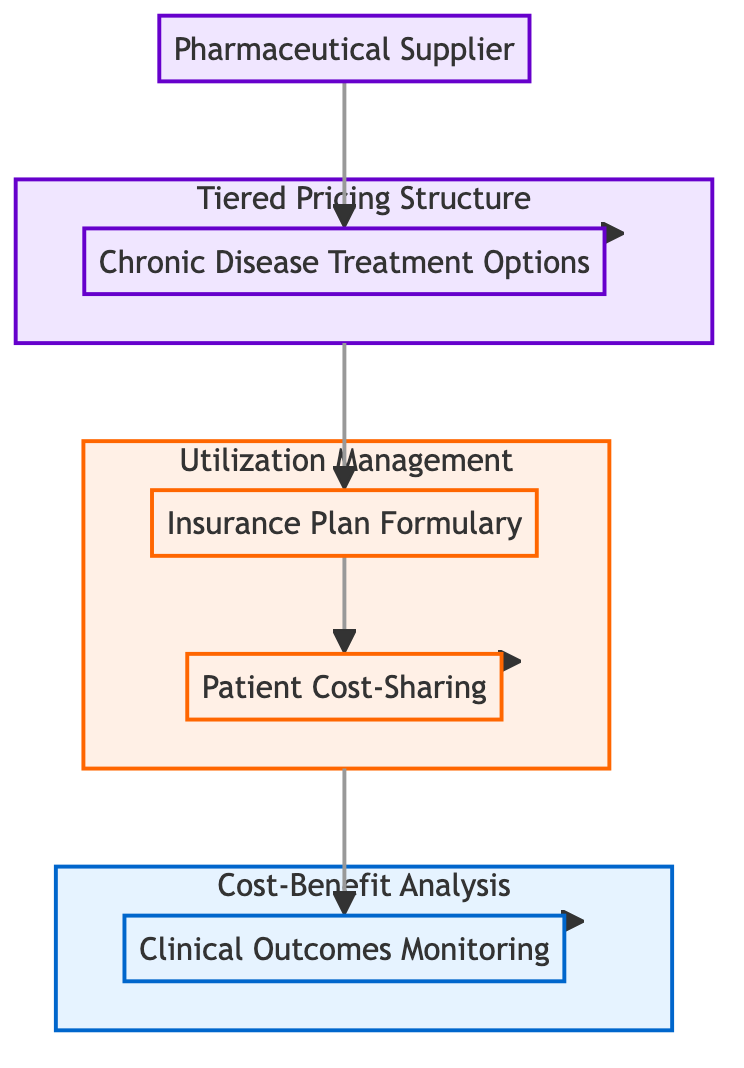What is the starting point of the flowchart? The flowchart begins with the "Pharmaceutical Supplier" node, which is the primary source of medications for chronic diseases. It is the first element that connects to the rest of the flowchart, establishing the origin of the processes depicted.
Answer: Pharmaceutical Supplier How many main subgraphs are present in the diagram? The diagram contains three main subgraphs: Cost-Benefit Analysis, Utilization Management, and Tiered Pricing Structure. Each subgraph encapsulates a set of related elements that contribute to the overall analysis.
Answer: 3 Which node directly follows "Chronic Disease Treatment Options"? The node that follows "Chronic Disease Treatment Options" is "Tiered Pricing Structure." This indicates the relationship where the treatment options are categorized into a pricing model.
Answer: Tiered Pricing Structure What type of management is included in the utilization management subgraph? The utilization management subgraph includes "Patient Cost-Sharing" as a component, which involves strategies to manage what patients pay out-of-pocket for medications.
Answer: Patient Cost-Sharing How does clinical outcomes monitoring relate to cost-benefit analysis? "Clinical Outcomes Monitoring" is a component within the "Cost-Benefit Analysis" subgraph, suggesting that the effectiveness and side effects of treatments are evaluated to assess their economic value.
Answer: Clinical Outcomes Monitoring What connects the "Insurance Plan Formulary" to "Patient Cost-Sharing"? The connection between "Insurance Plan Formulary" and "Patient Cost-Sharing" is that the formulary lists covered medications and their respective costs, which determine the out-of-pocket expenses patients have to pay.
Answer: Insurance Plan Formulary What is the relationship between "Utilization Management" and "Clinical Outcomes Monitoring"? "Utilization Management" directly leads to "Clinical Outcomes Monitoring" in the flowchart, showing that managing medication usage impacts the tracking of treatment effectiveness and side effects.
Answer: Direct relationship Which element represents a pricing model in the flowchart? The element that embodies the pricing model is "Tiered Pricing Structure," which categorizes medications into different tiers based on various factors, affecting how they are covered by insurance.
Answer: Tiered Pricing Structure 